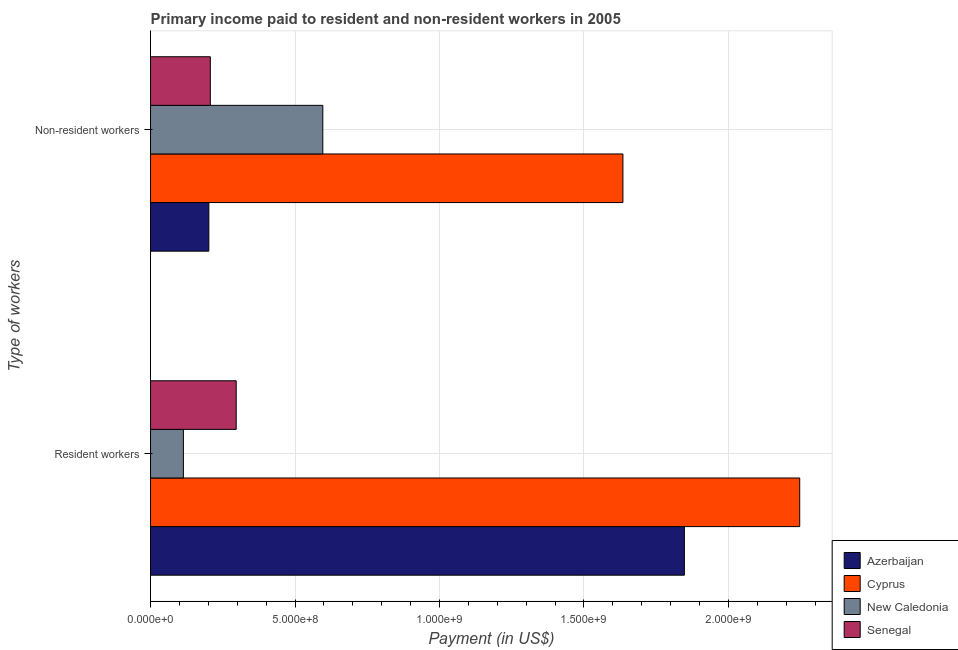How many groups of bars are there?
Your answer should be compact. 2. Are the number of bars per tick equal to the number of legend labels?
Ensure brevity in your answer.  Yes. Are the number of bars on each tick of the Y-axis equal?
Keep it short and to the point. Yes. How many bars are there on the 1st tick from the bottom?
Your answer should be compact. 4. What is the label of the 2nd group of bars from the top?
Offer a very short reply. Resident workers. What is the payment made to resident workers in Senegal?
Offer a terse response. 2.96e+08. Across all countries, what is the maximum payment made to non-resident workers?
Make the answer very short. 1.63e+09. Across all countries, what is the minimum payment made to resident workers?
Keep it short and to the point. 1.14e+08. In which country was the payment made to resident workers maximum?
Keep it short and to the point. Cyprus. In which country was the payment made to resident workers minimum?
Offer a terse response. New Caledonia. What is the total payment made to resident workers in the graph?
Give a very brief answer. 4.50e+09. What is the difference between the payment made to non-resident workers in New Caledonia and that in Azerbaijan?
Provide a succinct answer. 3.94e+08. What is the difference between the payment made to non-resident workers in New Caledonia and the payment made to resident workers in Azerbaijan?
Offer a terse response. -1.25e+09. What is the average payment made to non-resident workers per country?
Your answer should be compact. 6.60e+08. What is the difference between the payment made to resident workers and payment made to non-resident workers in Cyprus?
Your answer should be compact. 6.12e+08. What is the ratio of the payment made to non-resident workers in Cyprus to that in Senegal?
Ensure brevity in your answer.  7.9. In how many countries, is the payment made to resident workers greater than the average payment made to resident workers taken over all countries?
Provide a succinct answer. 2. What does the 4th bar from the top in Non-resident workers represents?
Your answer should be compact. Azerbaijan. What does the 3rd bar from the bottom in Resident workers represents?
Ensure brevity in your answer.  New Caledonia. How many bars are there?
Offer a very short reply. 8. Are all the bars in the graph horizontal?
Make the answer very short. Yes. What is the difference between two consecutive major ticks on the X-axis?
Ensure brevity in your answer.  5.00e+08. Are the values on the major ticks of X-axis written in scientific E-notation?
Your response must be concise. Yes. What is the title of the graph?
Provide a short and direct response. Primary income paid to resident and non-resident workers in 2005. What is the label or title of the X-axis?
Offer a very short reply. Payment (in US$). What is the label or title of the Y-axis?
Give a very brief answer. Type of workers. What is the Payment (in US$) in Azerbaijan in Resident workers?
Your response must be concise. 1.85e+09. What is the Payment (in US$) in Cyprus in Resident workers?
Keep it short and to the point. 2.25e+09. What is the Payment (in US$) in New Caledonia in Resident workers?
Make the answer very short. 1.14e+08. What is the Payment (in US$) in Senegal in Resident workers?
Provide a short and direct response. 2.96e+08. What is the Payment (in US$) in Azerbaijan in Non-resident workers?
Your answer should be compact. 2.02e+08. What is the Payment (in US$) of Cyprus in Non-resident workers?
Give a very brief answer. 1.63e+09. What is the Payment (in US$) of New Caledonia in Non-resident workers?
Provide a short and direct response. 5.96e+08. What is the Payment (in US$) of Senegal in Non-resident workers?
Give a very brief answer. 2.07e+08. Across all Type of workers, what is the maximum Payment (in US$) in Azerbaijan?
Your answer should be compact. 1.85e+09. Across all Type of workers, what is the maximum Payment (in US$) in Cyprus?
Provide a succinct answer. 2.25e+09. Across all Type of workers, what is the maximum Payment (in US$) in New Caledonia?
Provide a succinct answer. 5.96e+08. Across all Type of workers, what is the maximum Payment (in US$) in Senegal?
Keep it short and to the point. 2.96e+08. Across all Type of workers, what is the minimum Payment (in US$) in Azerbaijan?
Your answer should be very brief. 2.02e+08. Across all Type of workers, what is the minimum Payment (in US$) in Cyprus?
Give a very brief answer. 1.63e+09. Across all Type of workers, what is the minimum Payment (in US$) in New Caledonia?
Your response must be concise. 1.14e+08. Across all Type of workers, what is the minimum Payment (in US$) of Senegal?
Give a very brief answer. 2.07e+08. What is the total Payment (in US$) of Azerbaijan in the graph?
Your response must be concise. 2.05e+09. What is the total Payment (in US$) in Cyprus in the graph?
Ensure brevity in your answer.  3.88e+09. What is the total Payment (in US$) of New Caledonia in the graph?
Give a very brief answer. 7.10e+08. What is the total Payment (in US$) in Senegal in the graph?
Offer a very short reply. 5.03e+08. What is the difference between the Payment (in US$) of Azerbaijan in Resident workers and that in Non-resident workers?
Your response must be concise. 1.65e+09. What is the difference between the Payment (in US$) in Cyprus in Resident workers and that in Non-resident workers?
Provide a succinct answer. 6.12e+08. What is the difference between the Payment (in US$) of New Caledonia in Resident workers and that in Non-resident workers?
Provide a short and direct response. -4.82e+08. What is the difference between the Payment (in US$) in Senegal in Resident workers and that in Non-resident workers?
Offer a terse response. 8.96e+07. What is the difference between the Payment (in US$) of Azerbaijan in Resident workers and the Payment (in US$) of Cyprus in Non-resident workers?
Your response must be concise. 2.13e+08. What is the difference between the Payment (in US$) in Azerbaijan in Resident workers and the Payment (in US$) in New Caledonia in Non-resident workers?
Your answer should be very brief. 1.25e+09. What is the difference between the Payment (in US$) of Azerbaijan in Resident workers and the Payment (in US$) of Senegal in Non-resident workers?
Ensure brevity in your answer.  1.64e+09. What is the difference between the Payment (in US$) in Cyprus in Resident workers and the Payment (in US$) in New Caledonia in Non-resident workers?
Your answer should be compact. 1.65e+09. What is the difference between the Payment (in US$) in Cyprus in Resident workers and the Payment (in US$) in Senegal in Non-resident workers?
Make the answer very short. 2.04e+09. What is the difference between the Payment (in US$) in New Caledonia in Resident workers and the Payment (in US$) in Senegal in Non-resident workers?
Your response must be concise. -9.32e+07. What is the average Payment (in US$) in Azerbaijan per Type of workers?
Ensure brevity in your answer.  1.02e+09. What is the average Payment (in US$) in Cyprus per Type of workers?
Keep it short and to the point. 1.94e+09. What is the average Payment (in US$) in New Caledonia per Type of workers?
Your answer should be compact. 3.55e+08. What is the average Payment (in US$) of Senegal per Type of workers?
Provide a succinct answer. 2.52e+08. What is the difference between the Payment (in US$) in Azerbaijan and Payment (in US$) in Cyprus in Resident workers?
Provide a succinct answer. -3.99e+08. What is the difference between the Payment (in US$) in Azerbaijan and Payment (in US$) in New Caledonia in Resident workers?
Your response must be concise. 1.73e+09. What is the difference between the Payment (in US$) of Azerbaijan and Payment (in US$) of Senegal in Resident workers?
Your answer should be compact. 1.55e+09. What is the difference between the Payment (in US$) of Cyprus and Payment (in US$) of New Caledonia in Resident workers?
Provide a succinct answer. 2.13e+09. What is the difference between the Payment (in US$) of Cyprus and Payment (in US$) of Senegal in Resident workers?
Keep it short and to the point. 1.95e+09. What is the difference between the Payment (in US$) of New Caledonia and Payment (in US$) of Senegal in Resident workers?
Offer a very short reply. -1.83e+08. What is the difference between the Payment (in US$) in Azerbaijan and Payment (in US$) in Cyprus in Non-resident workers?
Your answer should be very brief. -1.43e+09. What is the difference between the Payment (in US$) of Azerbaijan and Payment (in US$) of New Caledonia in Non-resident workers?
Offer a terse response. -3.94e+08. What is the difference between the Payment (in US$) of Azerbaijan and Payment (in US$) of Senegal in Non-resident workers?
Make the answer very short. -5.11e+06. What is the difference between the Payment (in US$) in Cyprus and Payment (in US$) in New Caledonia in Non-resident workers?
Your response must be concise. 1.04e+09. What is the difference between the Payment (in US$) in Cyprus and Payment (in US$) in Senegal in Non-resident workers?
Your answer should be very brief. 1.43e+09. What is the difference between the Payment (in US$) of New Caledonia and Payment (in US$) of Senegal in Non-resident workers?
Keep it short and to the point. 3.89e+08. What is the ratio of the Payment (in US$) of Azerbaijan in Resident workers to that in Non-resident workers?
Ensure brevity in your answer.  9.15. What is the ratio of the Payment (in US$) in Cyprus in Resident workers to that in Non-resident workers?
Your response must be concise. 1.37. What is the ratio of the Payment (in US$) in New Caledonia in Resident workers to that in Non-resident workers?
Your answer should be very brief. 0.19. What is the ratio of the Payment (in US$) of Senegal in Resident workers to that in Non-resident workers?
Offer a terse response. 1.43. What is the difference between the highest and the second highest Payment (in US$) of Azerbaijan?
Provide a short and direct response. 1.65e+09. What is the difference between the highest and the second highest Payment (in US$) of Cyprus?
Your response must be concise. 6.12e+08. What is the difference between the highest and the second highest Payment (in US$) in New Caledonia?
Your answer should be compact. 4.82e+08. What is the difference between the highest and the second highest Payment (in US$) in Senegal?
Make the answer very short. 8.96e+07. What is the difference between the highest and the lowest Payment (in US$) of Azerbaijan?
Offer a terse response. 1.65e+09. What is the difference between the highest and the lowest Payment (in US$) in Cyprus?
Give a very brief answer. 6.12e+08. What is the difference between the highest and the lowest Payment (in US$) in New Caledonia?
Your answer should be compact. 4.82e+08. What is the difference between the highest and the lowest Payment (in US$) in Senegal?
Make the answer very short. 8.96e+07. 